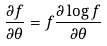<formula> <loc_0><loc_0><loc_500><loc_500>\frac { \partial f } { \partial \theta } = f \frac { \partial \log f } { \partial \theta }</formula> 